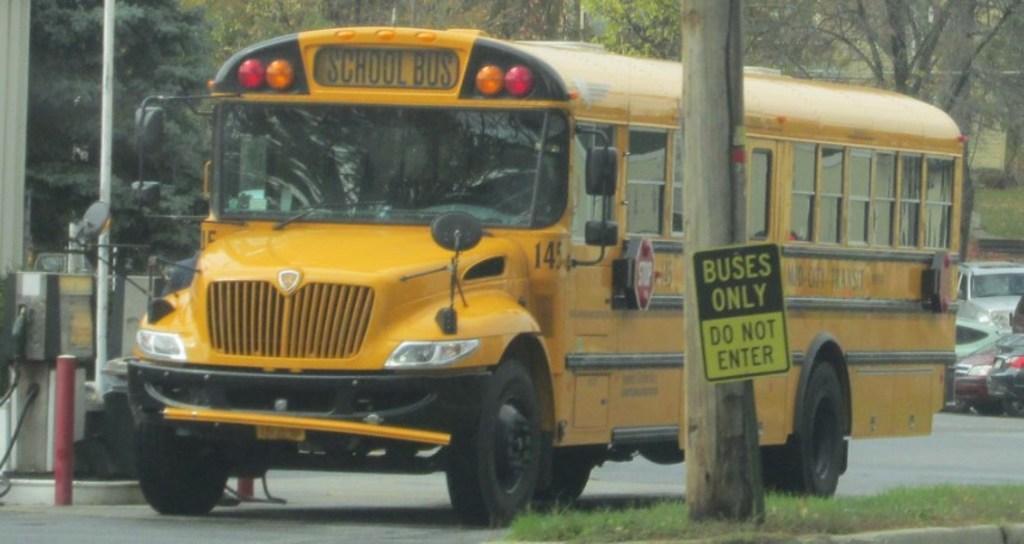Describe this image in one or two sentences. In the center of the image we can see a bus on the road and there are cars. On the right there is a pole and we can see a board placed on the pole. At the bottom there is grass. In the background there are trees. 